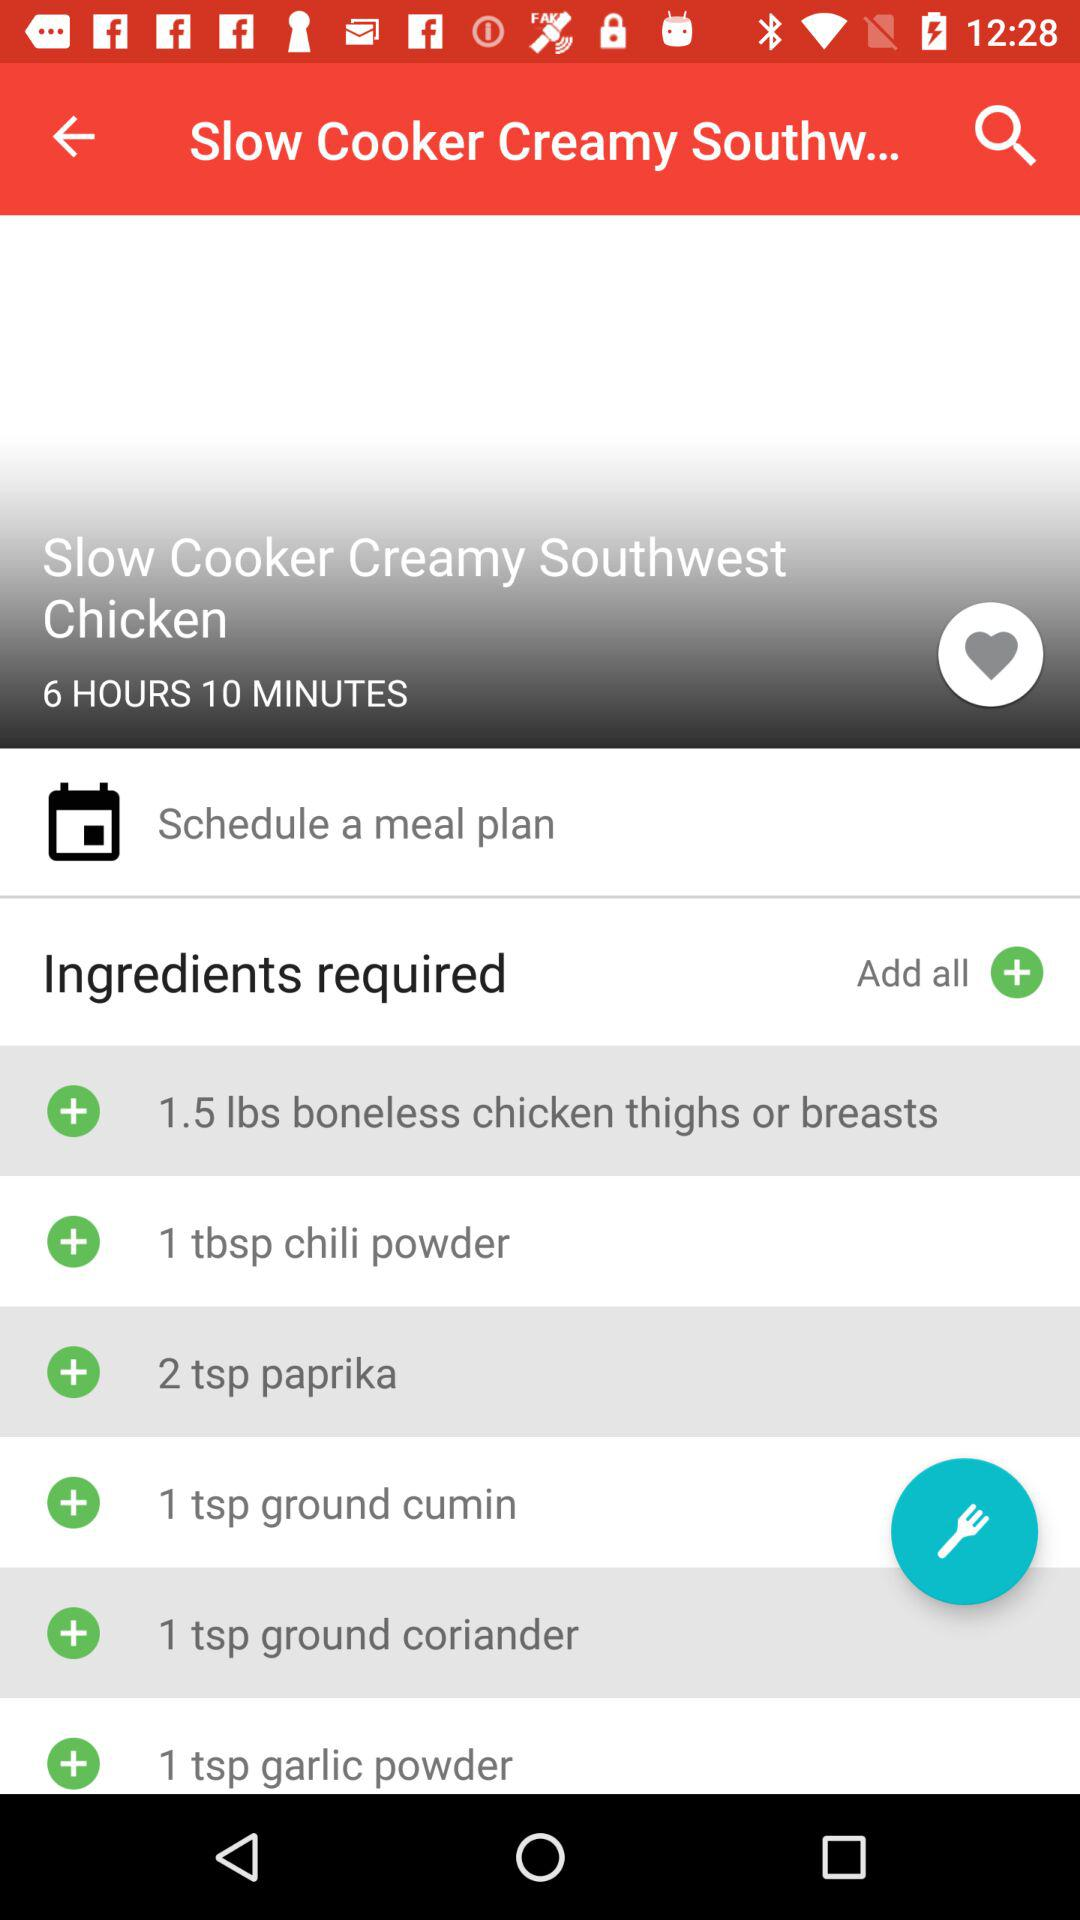2 teaspoons of which spice are required? 2 teaspoons of paprika spice are required. 